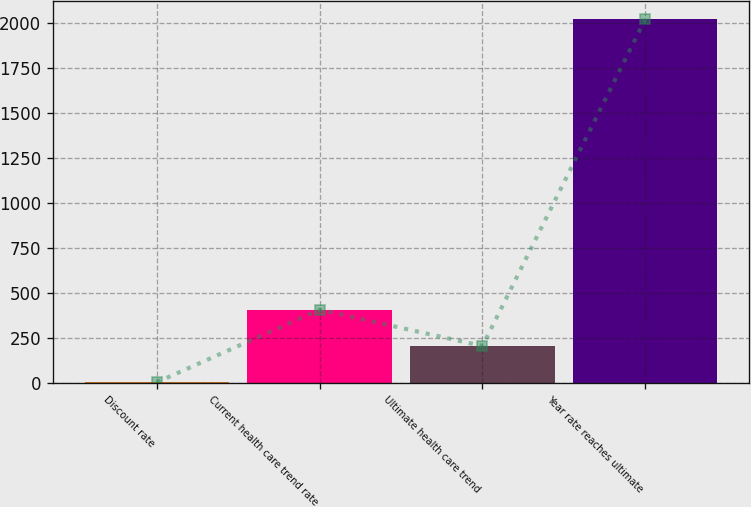Convert chart to OTSL. <chart><loc_0><loc_0><loc_500><loc_500><bar_chart><fcel>Discount rate<fcel>Current health care trend rate<fcel>Ultimate health care trend<fcel>Year rate reaches ultimate<nl><fcel>3.8<fcel>407.44<fcel>205.62<fcel>2022<nl></chart> 